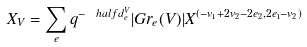<formula> <loc_0><loc_0><loc_500><loc_500>X _ { V } = \sum _ { e } q ^ { - \ h a l f d _ { e } ^ { V } } | G r _ { e } ( V ) | X ^ { ( - v _ { 1 } + 2 v _ { 2 } - 2 e _ { 2 } , 2 e _ { 1 } - v _ { 2 } ) }</formula> 